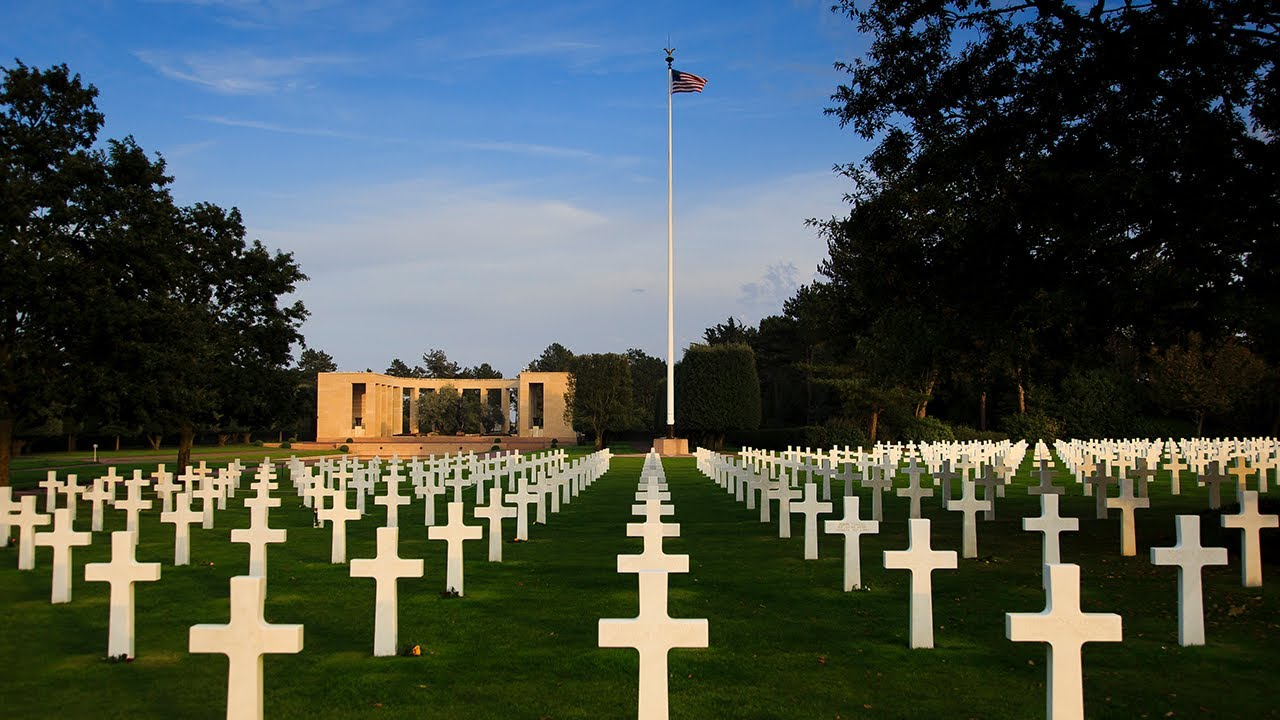What do you think is going on in this snapshot?
 The image captures the American Cemetery at Omaha Beach in France, a solemn reminder of the sacrifices made during the D-Day invasion of Normandy. The perspective is from a low angle, looking up at the countless white crosses that stand in neat rows, each marking the final resting place of an American soldier. The crosses, stark white against the vibrant green grass, stretch out seemingly endlessly, a poignant testament to the scale of loss. In the background, an American flag flies at half-mast, a symbol of respect and mourning. The sky above is a clear blue, adding a sense of tranquility to the scene. Despite the somber subject, the image conveys a sense of peace and reverence. 